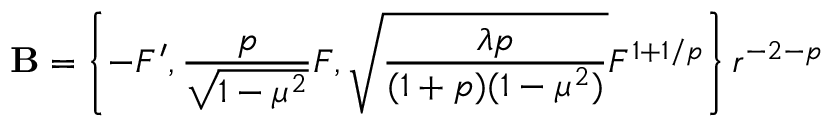<formula> <loc_0><loc_0><loc_500><loc_500>{ B } = \left \{ - { F } ^ { \prime } , \frac { p } { \sqrt { 1 - \mu ^ { 2 } } } { F } , \sqrt { \frac { \lambda p } { ( 1 + p ) ( 1 - \mu ^ { 2 } ) } } { F } ^ { 1 + 1 / p } \right \} r ^ { - 2 - p }</formula> 